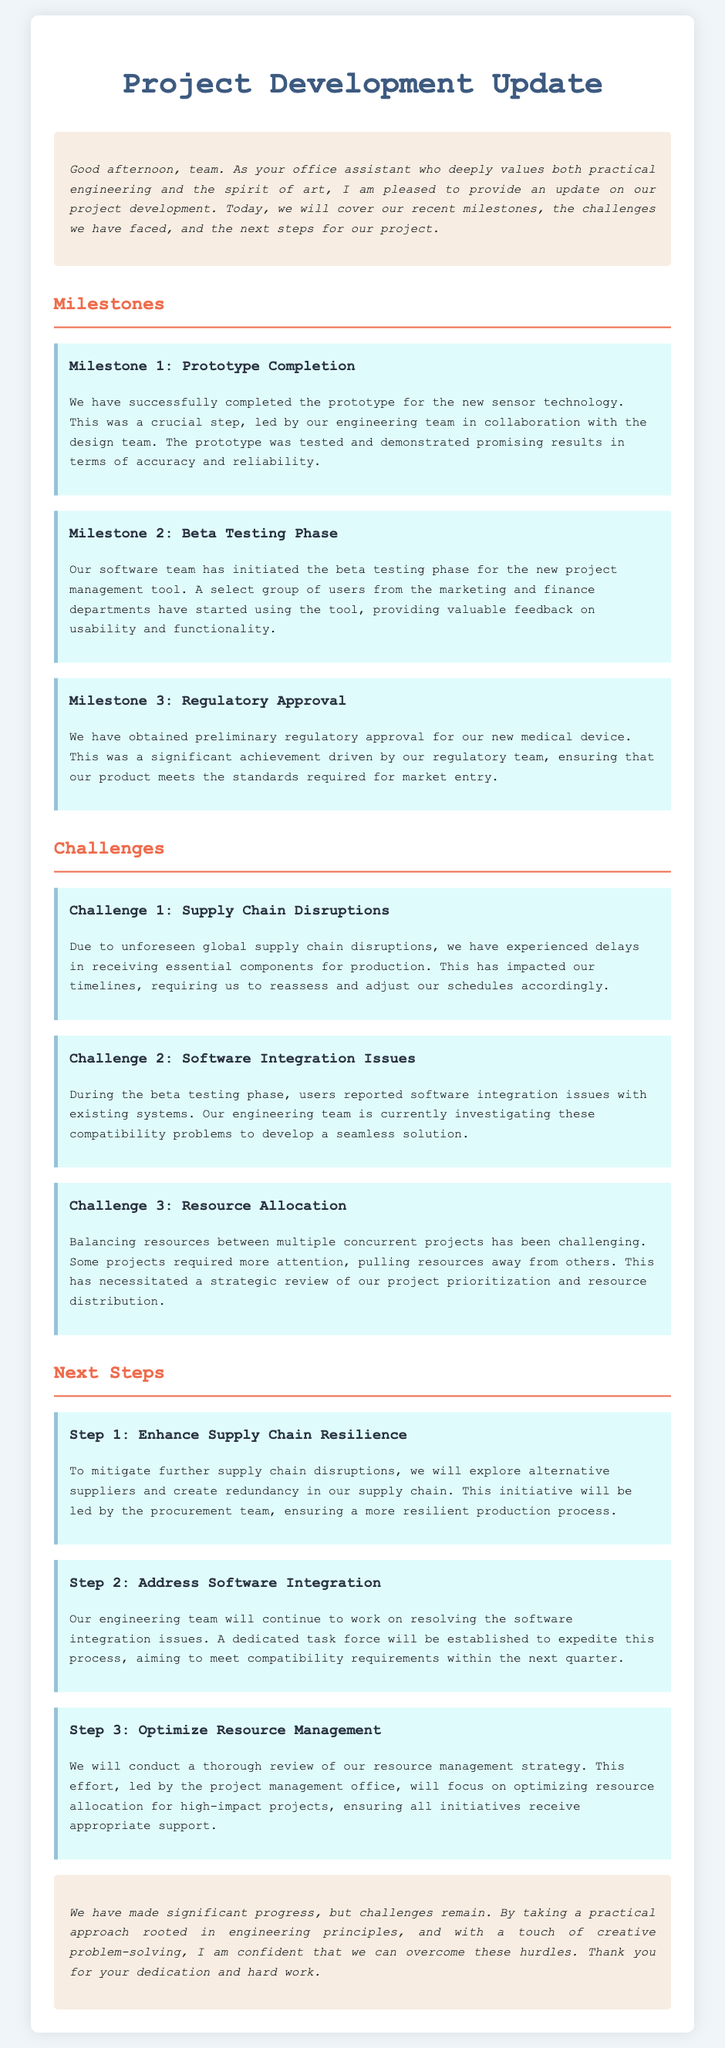What is the title of the project update? The title is presented at the top of the document and identifies the content it covers.
Answer: Project Development Update Who led the completion of the prototype? The document states that the engineering team collaborated with the design team for this milestone.
Answer: Engineering team What is the current phase of the new project management tool? The document mentions that a specific phase has begun for the tool, indicating its progress in development.
Answer: Beta testing phase What challenge is associated with resource management? The document specifies the nature of the challenge with regard to balancing resources, impacting project timelines.
Answer: Resource allocation What will be the focus of the procurement team's next steps? The document outlines the aims of the procurement team to deal with previously mentioned issues, highlighting their priorities moving forward.
Answer: Enhance supply chain resilience How many milestones are mentioned in the document? The document lists distinct milestones achieved, and counting these is critical to understanding project progress.
Answer: Three What is a significant achievement regarding regulatory aspects? The document highlights a specific accomplishment related to obtaining necessary approvals to proceed with the project.
Answer: Preliminary regulatory approval What will the project management office review? This office is responsible for an important aspect of managing the project's resources, as identified in the document's next steps section.
Answer: Resource management strategy 